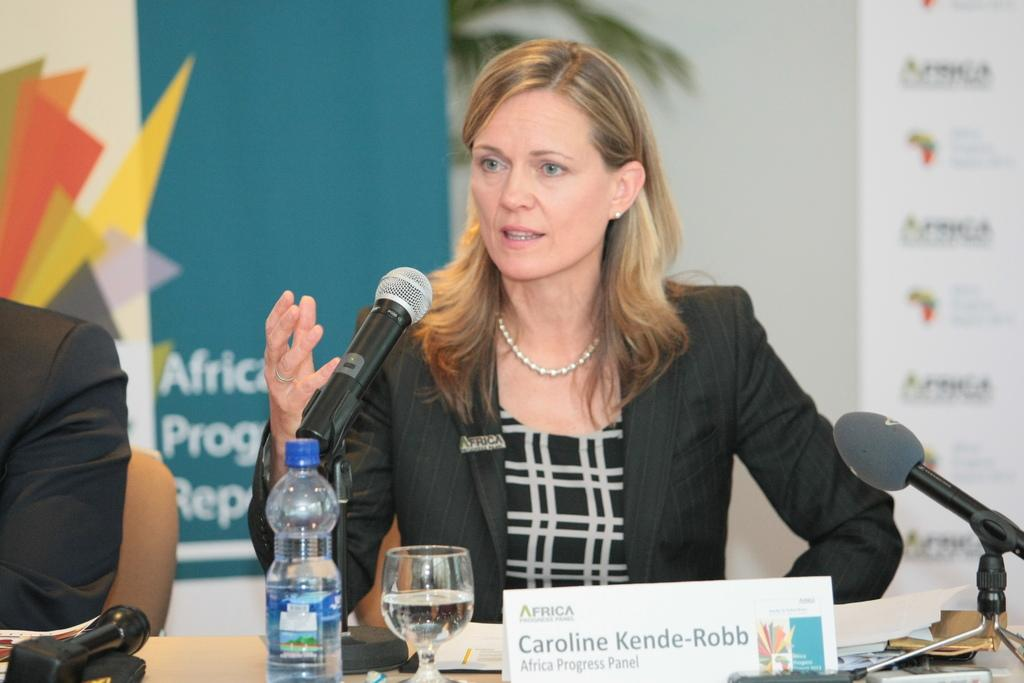Who is the main subject in the image? There is a woman in the image. What is the woman doing in the image? The woman is talking on a mic. What objects can be seen in the image besides the woman? There is a bottle, a glass, a name board, and a banner in the background of the image. Are there any other people in the image? Yes, there is a man in the image. What type of arithmetic problem is the woman solving on the mic? There is no arithmetic problem being solved on the mic in the image. What idea does the banner in the background represent? The banner in the background does not represent any specific idea, as it is not clear what is written on it. 